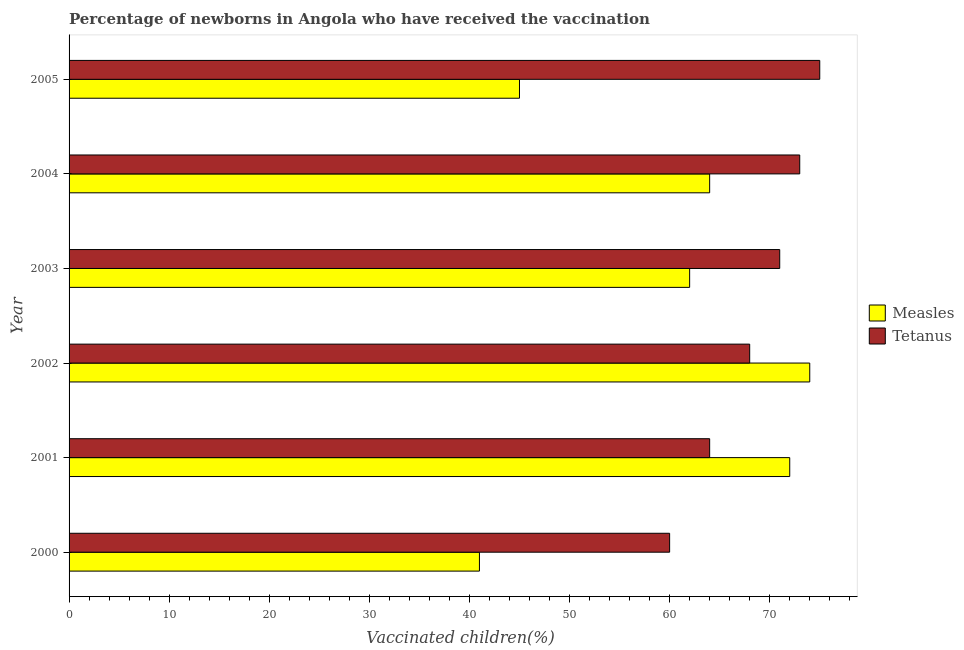How many bars are there on the 6th tick from the top?
Make the answer very short. 2. What is the percentage of newborns who received vaccination for measles in 2005?
Make the answer very short. 45. Across all years, what is the maximum percentage of newborns who received vaccination for tetanus?
Provide a short and direct response. 75. Across all years, what is the minimum percentage of newborns who received vaccination for measles?
Your answer should be compact. 41. In which year was the percentage of newborns who received vaccination for tetanus minimum?
Ensure brevity in your answer.  2000. What is the total percentage of newborns who received vaccination for measles in the graph?
Keep it short and to the point. 358. What is the difference between the percentage of newborns who received vaccination for tetanus in 2003 and that in 2005?
Provide a short and direct response. -4. What is the difference between the percentage of newborns who received vaccination for measles in 2001 and the percentage of newborns who received vaccination for tetanus in 2005?
Your response must be concise. -3. What is the average percentage of newborns who received vaccination for tetanus per year?
Keep it short and to the point. 68.5. What is the ratio of the percentage of newborns who received vaccination for tetanus in 2001 to that in 2004?
Offer a terse response. 0.88. Is the difference between the percentage of newborns who received vaccination for measles in 2004 and 2005 greater than the difference between the percentage of newborns who received vaccination for tetanus in 2004 and 2005?
Your answer should be compact. Yes. What is the difference between the highest and the second highest percentage of newborns who received vaccination for measles?
Your response must be concise. 2. What is the difference between the highest and the lowest percentage of newborns who received vaccination for measles?
Your answer should be compact. 33. In how many years, is the percentage of newborns who received vaccination for tetanus greater than the average percentage of newborns who received vaccination for tetanus taken over all years?
Ensure brevity in your answer.  3. Is the sum of the percentage of newborns who received vaccination for measles in 2001 and 2002 greater than the maximum percentage of newborns who received vaccination for tetanus across all years?
Make the answer very short. Yes. What does the 2nd bar from the top in 2003 represents?
Your response must be concise. Measles. What does the 1st bar from the bottom in 2001 represents?
Your response must be concise. Measles. How many bars are there?
Provide a succinct answer. 12. How many years are there in the graph?
Give a very brief answer. 6. What is the difference between two consecutive major ticks on the X-axis?
Offer a very short reply. 10. Does the graph contain any zero values?
Offer a very short reply. No. How are the legend labels stacked?
Your answer should be compact. Vertical. What is the title of the graph?
Offer a very short reply. Percentage of newborns in Angola who have received the vaccination. What is the label or title of the X-axis?
Your response must be concise. Vaccinated children(%)
. What is the label or title of the Y-axis?
Give a very brief answer. Year. What is the Vaccinated children(%)
 in Measles in 2001?
Give a very brief answer. 72. What is the Vaccinated children(%)
 in Measles in 2002?
Provide a succinct answer. 74. What is the Vaccinated children(%)
 in Measles in 2003?
Provide a succinct answer. 62. What is the Vaccinated children(%)
 in Tetanus in 2003?
Give a very brief answer. 71. What is the Vaccinated children(%)
 in Tetanus in 2004?
Give a very brief answer. 73. What is the Vaccinated children(%)
 of Measles in 2005?
Make the answer very short. 45. What is the Vaccinated children(%)
 in Tetanus in 2005?
Offer a terse response. 75. Across all years, what is the maximum Vaccinated children(%)
 of Measles?
Provide a short and direct response. 74. Across all years, what is the maximum Vaccinated children(%)
 in Tetanus?
Keep it short and to the point. 75. Across all years, what is the minimum Vaccinated children(%)
 in Measles?
Make the answer very short. 41. Across all years, what is the minimum Vaccinated children(%)
 of Tetanus?
Ensure brevity in your answer.  60. What is the total Vaccinated children(%)
 in Measles in the graph?
Keep it short and to the point. 358. What is the total Vaccinated children(%)
 in Tetanus in the graph?
Offer a terse response. 411. What is the difference between the Vaccinated children(%)
 of Measles in 2000 and that in 2001?
Your response must be concise. -31. What is the difference between the Vaccinated children(%)
 of Tetanus in 2000 and that in 2001?
Offer a very short reply. -4. What is the difference between the Vaccinated children(%)
 in Measles in 2000 and that in 2002?
Provide a succinct answer. -33. What is the difference between the Vaccinated children(%)
 of Tetanus in 2000 and that in 2002?
Your answer should be very brief. -8. What is the difference between the Vaccinated children(%)
 of Tetanus in 2000 and that in 2004?
Your answer should be compact. -13. What is the difference between the Vaccinated children(%)
 in Measles in 2000 and that in 2005?
Provide a succinct answer. -4. What is the difference between the Vaccinated children(%)
 in Measles in 2001 and that in 2002?
Provide a succinct answer. -2. What is the difference between the Vaccinated children(%)
 of Tetanus in 2001 and that in 2002?
Make the answer very short. -4. What is the difference between the Vaccinated children(%)
 in Measles in 2001 and that in 2005?
Your answer should be compact. 27. What is the difference between the Vaccinated children(%)
 in Tetanus in 2002 and that in 2003?
Your response must be concise. -3. What is the difference between the Vaccinated children(%)
 of Tetanus in 2002 and that in 2004?
Provide a short and direct response. -5. What is the difference between the Vaccinated children(%)
 in Measles in 2002 and that in 2005?
Your answer should be very brief. 29. What is the difference between the Vaccinated children(%)
 in Tetanus in 2002 and that in 2005?
Ensure brevity in your answer.  -7. What is the difference between the Vaccinated children(%)
 of Tetanus in 2003 and that in 2005?
Provide a succinct answer. -4. What is the difference between the Vaccinated children(%)
 in Measles in 2004 and that in 2005?
Provide a short and direct response. 19. What is the difference between the Vaccinated children(%)
 in Measles in 2000 and the Vaccinated children(%)
 in Tetanus in 2001?
Keep it short and to the point. -23. What is the difference between the Vaccinated children(%)
 of Measles in 2000 and the Vaccinated children(%)
 of Tetanus in 2004?
Your answer should be very brief. -32. What is the difference between the Vaccinated children(%)
 in Measles in 2000 and the Vaccinated children(%)
 in Tetanus in 2005?
Provide a short and direct response. -34. What is the difference between the Vaccinated children(%)
 of Measles in 2001 and the Vaccinated children(%)
 of Tetanus in 2003?
Make the answer very short. 1. What is the difference between the Vaccinated children(%)
 of Measles in 2001 and the Vaccinated children(%)
 of Tetanus in 2004?
Your answer should be compact. -1. What is the difference between the Vaccinated children(%)
 in Measles in 2002 and the Vaccinated children(%)
 in Tetanus in 2003?
Make the answer very short. 3. What is the difference between the Vaccinated children(%)
 in Measles in 2004 and the Vaccinated children(%)
 in Tetanus in 2005?
Your response must be concise. -11. What is the average Vaccinated children(%)
 of Measles per year?
Your answer should be compact. 59.67. What is the average Vaccinated children(%)
 in Tetanus per year?
Your answer should be very brief. 68.5. What is the ratio of the Vaccinated children(%)
 of Measles in 2000 to that in 2001?
Your answer should be very brief. 0.57. What is the ratio of the Vaccinated children(%)
 of Tetanus in 2000 to that in 2001?
Keep it short and to the point. 0.94. What is the ratio of the Vaccinated children(%)
 of Measles in 2000 to that in 2002?
Your answer should be compact. 0.55. What is the ratio of the Vaccinated children(%)
 in Tetanus in 2000 to that in 2002?
Offer a terse response. 0.88. What is the ratio of the Vaccinated children(%)
 in Measles in 2000 to that in 2003?
Make the answer very short. 0.66. What is the ratio of the Vaccinated children(%)
 of Tetanus in 2000 to that in 2003?
Ensure brevity in your answer.  0.85. What is the ratio of the Vaccinated children(%)
 in Measles in 2000 to that in 2004?
Give a very brief answer. 0.64. What is the ratio of the Vaccinated children(%)
 of Tetanus in 2000 to that in 2004?
Provide a succinct answer. 0.82. What is the ratio of the Vaccinated children(%)
 in Measles in 2000 to that in 2005?
Make the answer very short. 0.91. What is the ratio of the Vaccinated children(%)
 in Measles in 2001 to that in 2002?
Give a very brief answer. 0.97. What is the ratio of the Vaccinated children(%)
 of Tetanus in 2001 to that in 2002?
Your answer should be compact. 0.94. What is the ratio of the Vaccinated children(%)
 in Measles in 2001 to that in 2003?
Your answer should be compact. 1.16. What is the ratio of the Vaccinated children(%)
 in Tetanus in 2001 to that in 2003?
Offer a terse response. 0.9. What is the ratio of the Vaccinated children(%)
 in Tetanus in 2001 to that in 2004?
Keep it short and to the point. 0.88. What is the ratio of the Vaccinated children(%)
 of Measles in 2001 to that in 2005?
Your answer should be very brief. 1.6. What is the ratio of the Vaccinated children(%)
 of Tetanus in 2001 to that in 2005?
Your answer should be compact. 0.85. What is the ratio of the Vaccinated children(%)
 in Measles in 2002 to that in 2003?
Your answer should be compact. 1.19. What is the ratio of the Vaccinated children(%)
 of Tetanus in 2002 to that in 2003?
Offer a very short reply. 0.96. What is the ratio of the Vaccinated children(%)
 of Measles in 2002 to that in 2004?
Offer a very short reply. 1.16. What is the ratio of the Vaccinated children(%)
 of Tetanus in 2002 to that in 2004?
Your response must be concise. 0.93. What is the ratio of the Vaccinated children(%)
 of Measles in 2002 to that in 2005?
Your response must be concise. 1.64. What is the ratio of the Vaccinated children(%)
 in Tetanus in 2002 to that in 2005?
Offer a terse response. 0.91. What is the ratio of the Vaccinated children(%)
 in Measles in 2003 to that in 2004?
Your answer should be very brief. 0.97. What is the ratio of the Vaccinated children(%)
 of Tetanus in 2003 to that in 2004?
Your answer should be compact. 0.97. What is the ratio of the Vaccinated children(%)
 of Measles in 2003 to that in 2005?
Ensure brevity in your answer.  1.38. What is the ratio of the Vaccinated children(%)
 in Tetanus in 2003 to that in 2005?
Give a very brief answer. 0.95. What is the ratio of the Vaccinated children(%)
 in Measles in 2004 to that in 2005?
Ensure brevity in your answer.  1.42. What is the ratio of the Vaccinated children(%)
 of Tetanus in 2004 to that in 2005?
Offer a very short reply. 0.97. What is the difference between the highest and the second highest Vaccinated children(%)
 in Tetanus?
Keep it short and to the point. 2. What is the difference between the highest and the lowest Vaccinated children(%)
 in Measles?
Provide a succinct answer. 33. What is the difference between the highest and the lowest Vaccinated children(%)
 in Tetanus?
Give a very brief answer. 15. 